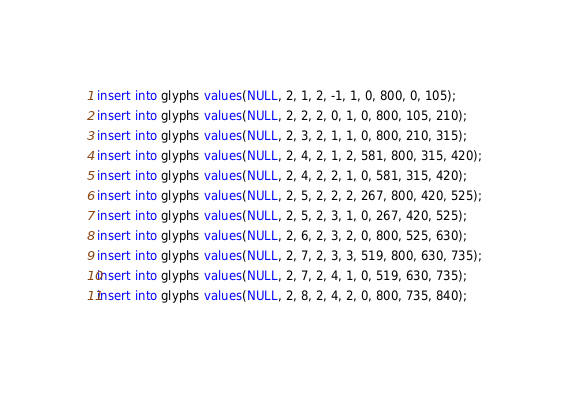<code> <loc_0><loc_0><loc_500><loc_500><_SQL_>insert into glyphs values(NULL, 2, 1, 2, -1, 1, 0, 800, 0, 105);
insert into glyphs values(NULL, 2, 2, 2, 0, 1, 0, 800, 105, 210);
insert into glyphs values(NULL, 2, 3, 2, 1, 1, 0, 800, 210, 315);
insert into glyphs values(NULL, 2, 4, 2, 1, 2, 581, 800, 315, 420);
insert into glyphs values(NULL, 2, 4, 2, 2, 1, 0, 581, 315, 420);
insert into glyphs values(NULL, 2, 5, 2, 2, 2, 267, 800, 420, 525);
insert into glyphs values(NULL, 2, 5, 2, 3, 1, 0, 267, 420, 525);
insert into glyphs values(NULL, 2, 6, 2, 3, 2, 0, 800, 525, 630);
insert into glyphs values(NULL, 2, 7, 2, 3, 3, 519, 800, 630, 735);
insert into glyphs values(NULL, 2, 7, 2, 4, 1, 0, 519, 630, 735);
insert into glyphs values(NULL, 2, 8, 2, 4, 2, 0, 800, 735, 840);
</code> 